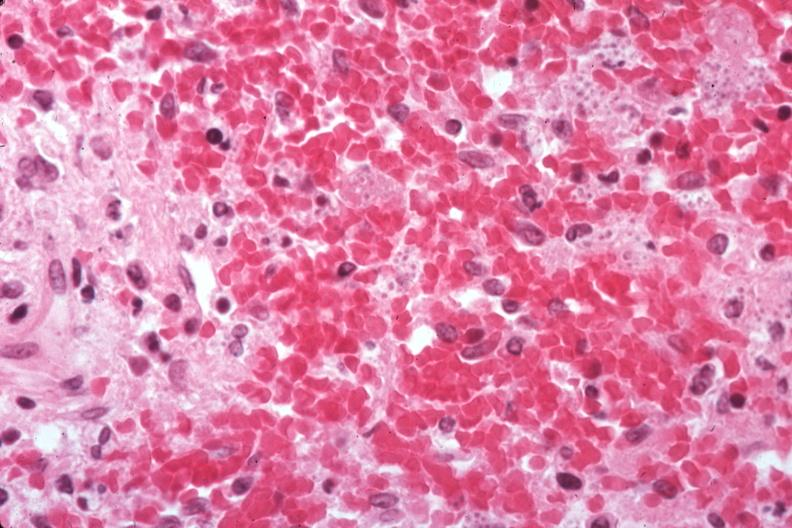s hematologic present?
Answer the question using a single word or phrase. Yes 